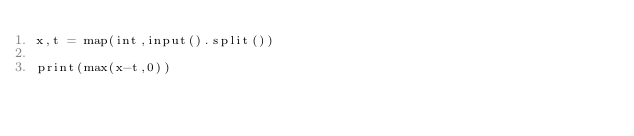Convert code to text. <code><loc_0><loc_0><loc_500><loc_500><_Python_>x,t = map(int,input().split())

print(max(x-t,0))</code> 